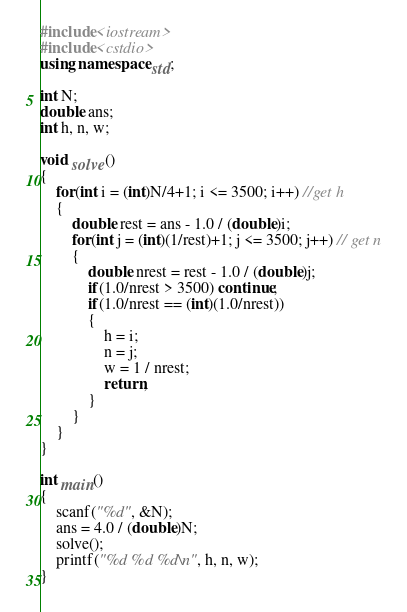<code> <loc_0><loc_0><loc_500><loc_500><_C++_>#include<iostream>
#include<cstdio>
using namespace std;

int N;
double ans;
int h, n, w;

void solve()
{
	for(int i = (int)N/4+1; i <= 3500; i++) //get h
	{
		double rest = ans - 1.0 / (double)i;
		for(int j = (int)(1/rest)+1; j <= 3500; j++) // get n
		{
			double nrest = rest - 1.0 / (double)j;
			if(1.0/nrest > 3500) continue;
			if(1.0/nrest == (int)(1.0/nrest)) 
			{
				h = i;
				n = j;
				w = 1 / nrest;
				return;
			}
		}
	}
}

int main()
{
	scanf("%d", &N);
	ans = 4.0 / (double)N;
	solve();
	printf("%d %d %d\n", h, n, w);
}

</code> 